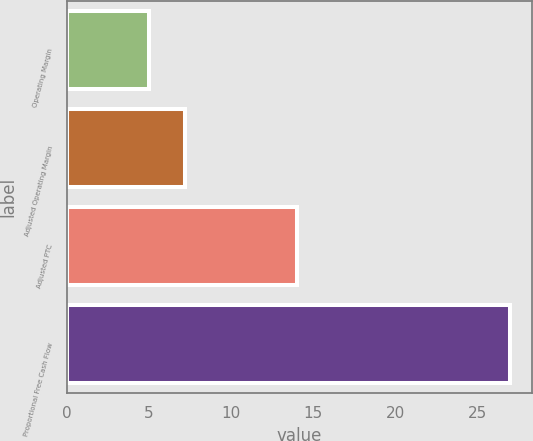<chart> <loc_0><loc_0><loc_500><loc_500><bar_chart><fcel>Operating Margin<fcel>Adjusted Operating Margin<fcel>Adjusted PTC<fcel>Proportional Free Cash Flow<nl><fcel>5<fcel>7.2<fcel>14<fcel>27<nl></chart> 